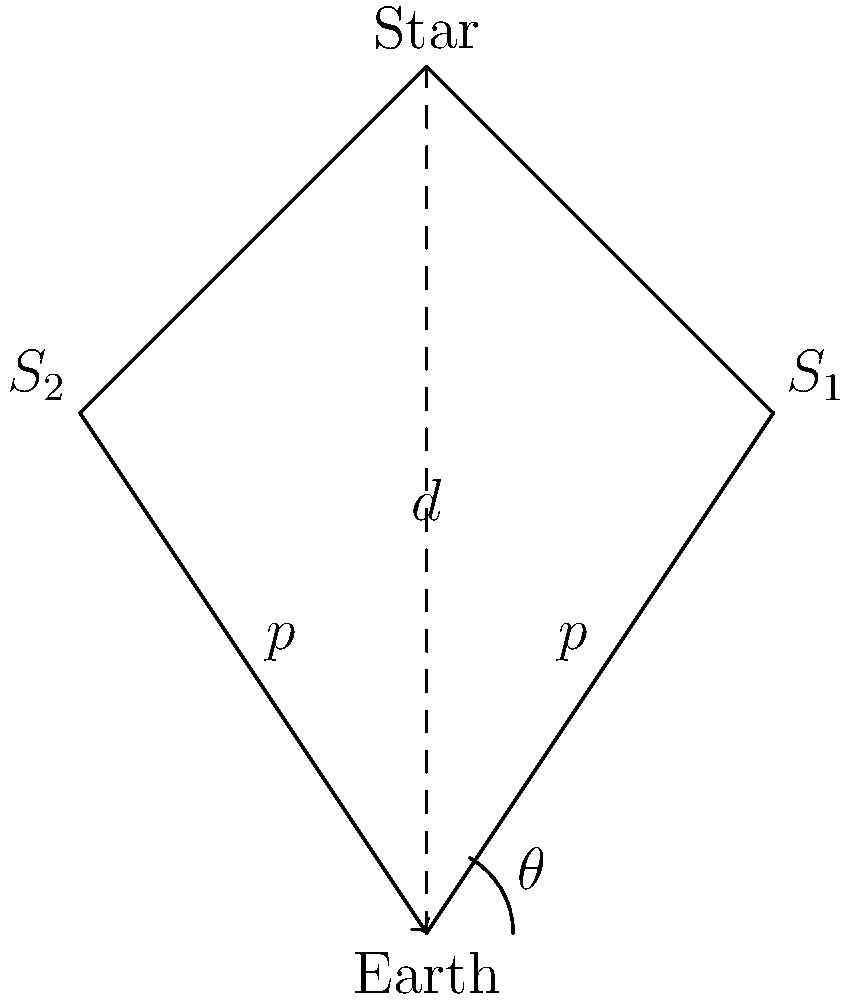In the parallax diagram above, a star is observed from two positions of Earth's orbit ($S_1$ and $S_2$) separated by 6 months. The parallax angle $\theta$ is measured to be 0.5 arcseconds. Given that 1 parsec is defined as the distance at which a star would have a parallax of 1 arcsecond, calculate the distance to the star in parsecs. To solve this problem, we'll follow these steps:

1) Recall the definition of a parsec: 1 parsec is the distance at which a star has a parallax of 1 arcsecond.

2) We can express this relationship mathematically as:

   $$d (\text{in parsecs}) = \frac{1}{\theta (\text{in arcseconds})}$$

3) In our case, we're given that $\theta = 0.5$ arcseconds.

4) Substituting this into our equation:

   $$d = \frac{1}{0.5} \text{ parsecs}$$

5) Simplify:

   $$d = 2 \text{ parsecs}$$

Therefore, the star is located at a distance of 2 parsecs from Earth.
Answer: 2 parsecs 